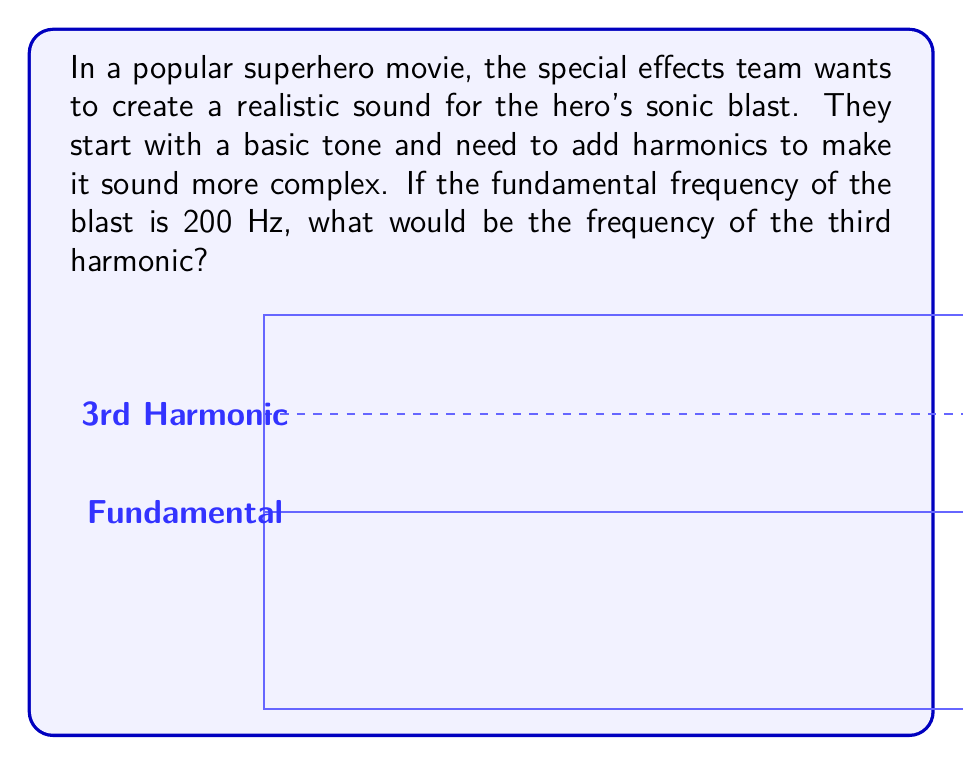Provide a solution to this math problem. To understand this, let's break it down step-by-step:

1. In sound design, Fourier transforms help break down complex sounds into simpler components called harmonics.

2. The fundamental frequency is the lowest and usually the strongest frequency in a sound. It's often referred to as the first harmonic.

3. Harmonics are whole number multiples of the fundamental frequency. They follow this pattern:
   - 1st harmonic (fundamental): $f$
   - 2nd harmonic: $2f$
   - 3rd harmonic: $3f$
   - 4th harmonic: $4f$
   And so on...

4. In this case, we're told the fundamental frequency is 200 Hz. So, $f = 200$ Hz.

5. We're asked about the 3rd harmonic, which would be $3f$.

6. To calculate the 3rd harmonic, we multiply the fundamental by 3:

   $3f = 3 \times 200 \text{ Hz} = 600 \text{ Hz}$

Therefore, the frequency of the third harmonic would be 600 Hz.

This higher frequency would add a brighter, more complex quality to the sound of the sonic blast, making it more interesting and realistic for the movie audience.
Answer: 600 Hz 